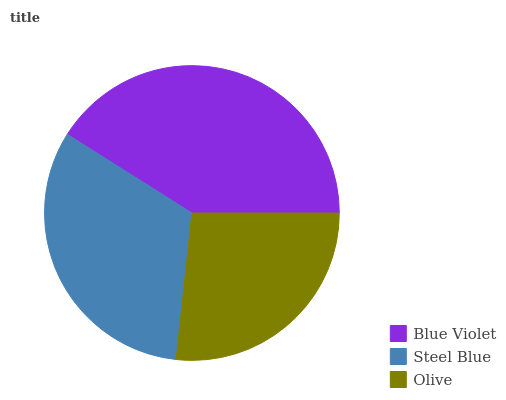Is Olive the minimum?
Answer yes or no. Yes. Is Blue Violet the maximum?
Answer yes or no. Yes. Is Steel Blue the minimum?
Answer yes or no. No. Is Steel Blue the maximum?
Answer yes or no. No. Is Blue Violet greater than Steel Blue?
Answer yes or no. Yes. Is Steel Blue less than Blue Violet?
Answer yes or no. Yes. Is Steel Blue greater than Blue Violet?
Answer yes or no. No. Is Blue Violet less than Steel Blue?
Answer yes or no. No. Is Steel Blue the high median?
Answer yes or no. Yes. Is Steel Blue the low median?
Answer yes or no. Yes. Is Blue Violet the high median?
Answer yes or no. No. Is Blue Violet the low median?
Answer yes or no. No. 